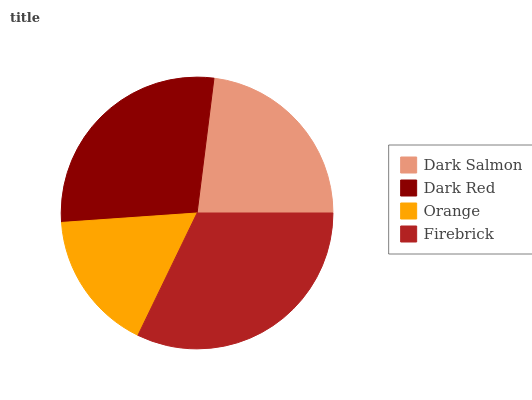Is Orange the minimum?
Answer yes or no. Yes. Is Firebrick the maximum?
Answer yes or no. Yes. Is Dark Red the minimum?
Answer yes or no. No. Is Dark Red the maximum?
Answer yes or no. No. Is Dark Red greater than Dark Salmon?
Answer yes or no. Yes. Is Dark Salmon less than Dark Red?
Answer yes or no. Yes. Is Dark Salmon greater than Dark Red?
Answer yes or no. No. Is Dark Red less than Dark Salmon?
Answer yes or no. No. Is Dark Red the high median?
Answer yes or no. Yes. Is Dark Salmon the low median?
Answer yes or no. Yes. Is Dark Salmon the high median?
Answer yes or no. No. Is Orange the low median?
Answer yes or no. No. 